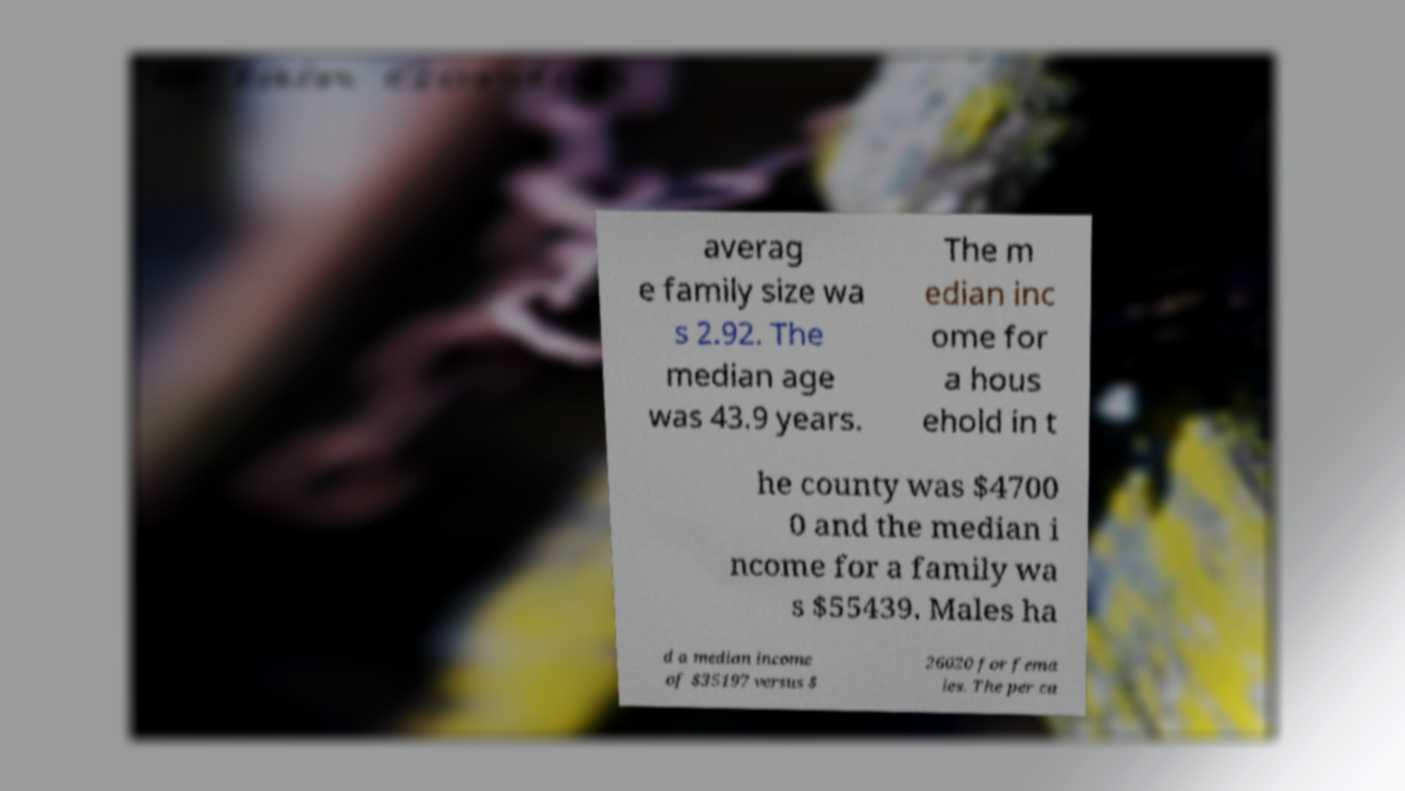There's text embedded in this image that I need extracted. Can you transcribe it verbatim? averag e family size wa s 2.92. The median age was 43.9 years. The m edian inc ome for a hous ehold in t he county was $4700 0 and the median i ncome for a family wa s $55439. Males ha d a median income of $35197 versus $ 26020 for fema les. The per ca 